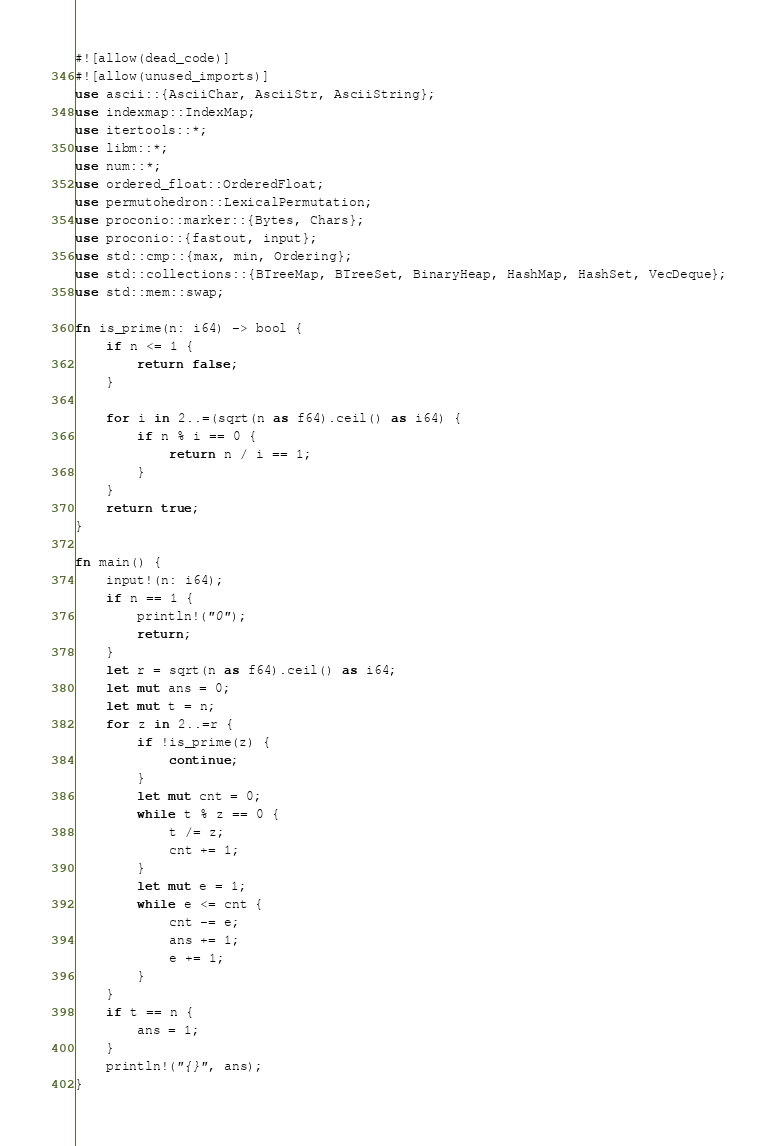Convert code to text. <code><loc_0><loc_0><loc_500><loc_500><_Rust_>#![allow(dead_code)]
#![allow(unused_imports)]
use ascii::{AsciiChar, AsciiStr, AsciiString};
use indexmap::IndexMap;
use itertools::*;
use libm::*;
use num::*;
use ordered_float::OrderedFloat;
use permutohedron::LexicalPermutation;
use proconio::marker::{Bytes, Chars};
use proconio::{fastout, input};
use std::cmp::{max, min, Ordering};
use std::collections::{BTreeMap, BTreeSet, BinaryHeap, HashMap, HashSet, VecDeque};
use std::mem::swap;

fn is_prime(n: i64) -> bool {
    if n <= 1 {
        return false;
    }

    for i in 2..=(sqrt(n as f64).ceil() as i64) {
        if n % i == 0 {
            return n / i == 1;
        }
    }
    return true;
}

fn main() {
    input!(n: i64);
    if n == 1 {
        println!("0");
        return;
    }
    let r = sqrt(n as f64).ceil() as i64;
    let mut ans = 0;
    let mut t = n;
    for z in 2..=r {
        if !is_prime(z) {
            continue;
        }
        let mut cnt = 0;
        while t % z == 0 {
            t /= z;
            cnt += 1;
        }
        let mut e = 1;
        while e <= cnt {
            cnt -= e;
            ans += 1;
            e += 1;
        }
    }
    if t == n {
        ans = 1;
    }
    println!("{}", ans);
}
</code> 